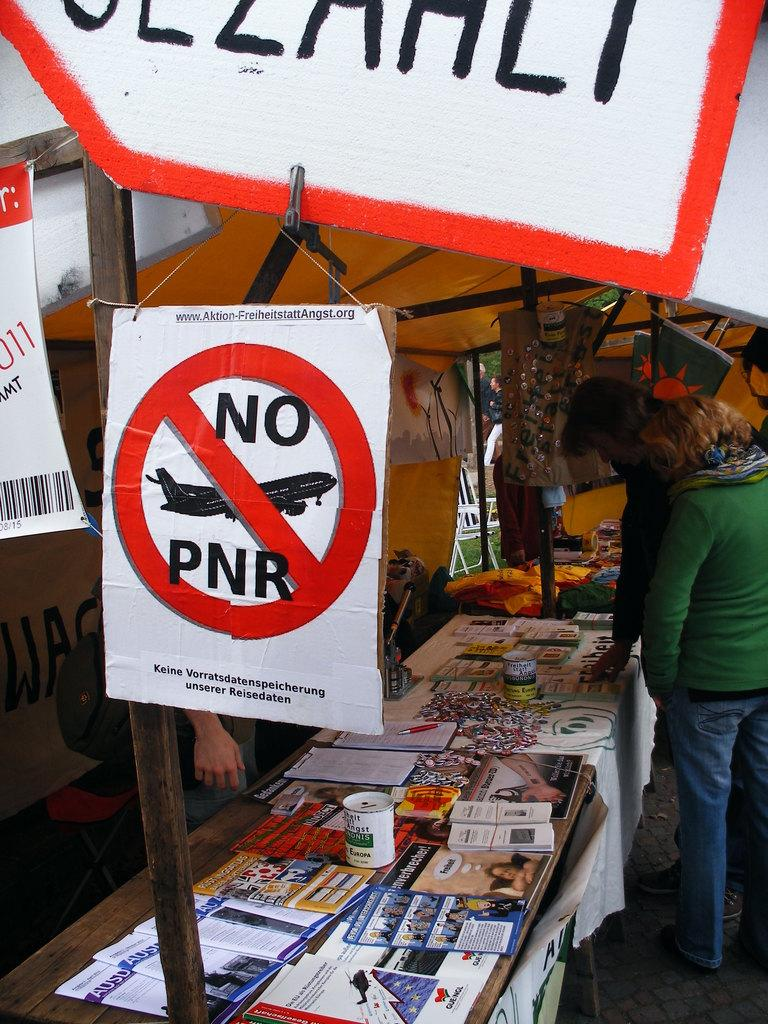<image>
Offer a succinct explanation of the picture presented. A roadside stand with the poster that has NO PNR written on it 